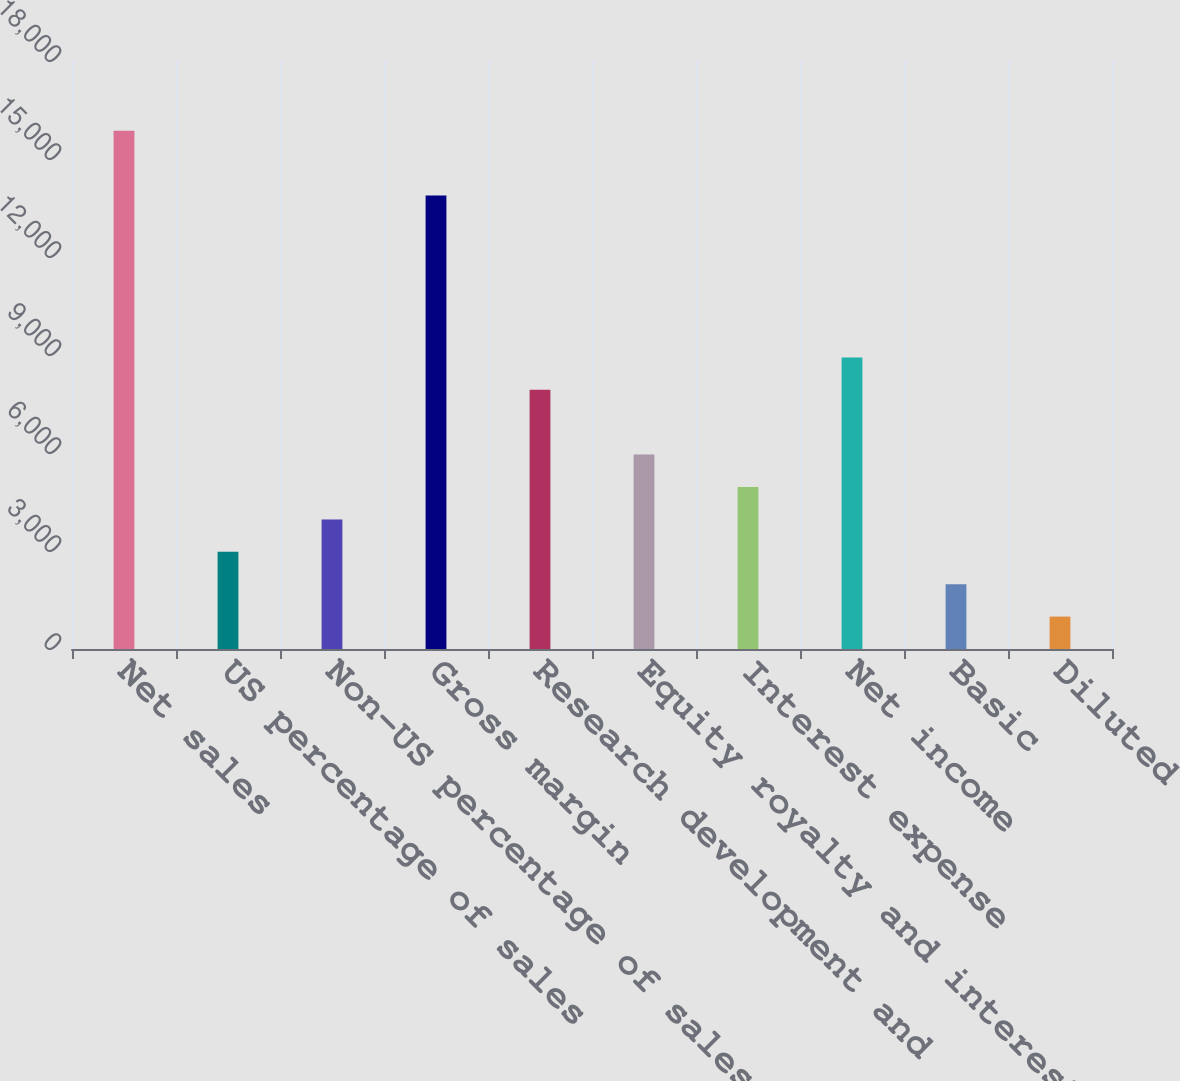Convert chart. <chart><loc_0><loc_0><loc_500><loc_500><bar_chart><fcel>Net sales<fcel>US percentage of sales<fcel>Non-US percentage of sales<fcel>Gross margin<fcel>Research development and<fcel>Equity royalty and interest<fcel>Interest expense<fcel>Net income<fcel>Basic<fcel>Diluted<nl><fcel>15868.6<fcel>2975.61<fcel>3967.38<fcel>13885.1<fcel>7934.46<fcel>5950.92<fcel>4959.15<fcel>8926.23<fcel>1983.84<fcel>992.07<nl></chart> 